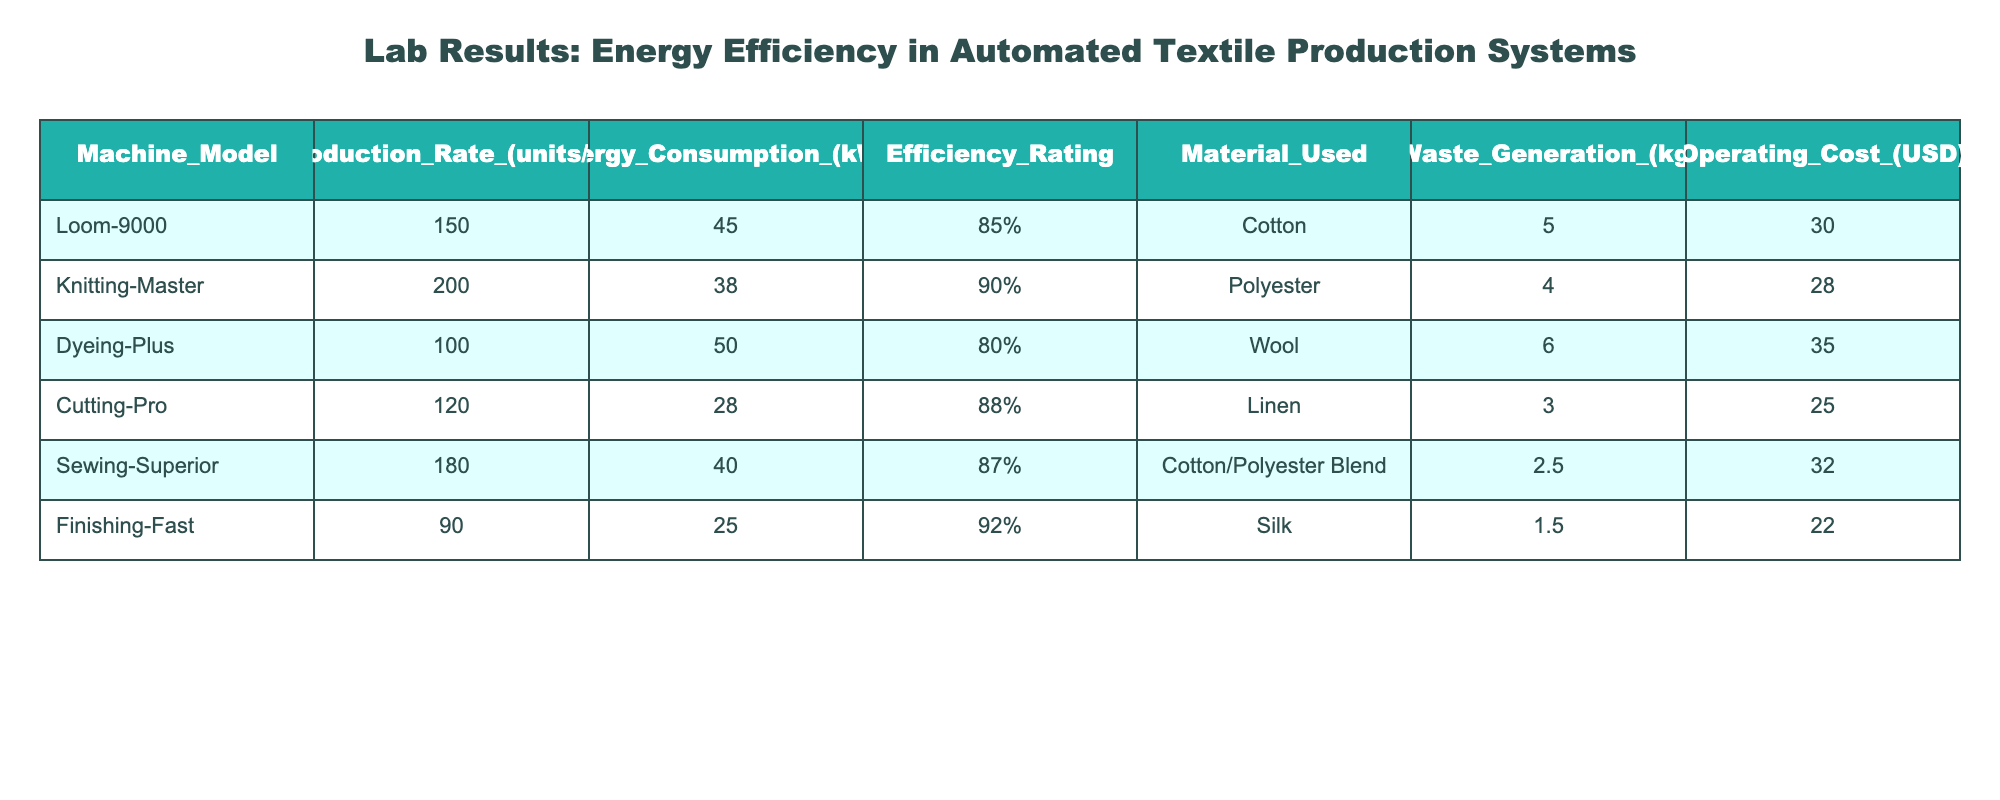What is the production rate of the Loom-9000? The production rate of the Loom-9000 is explicitly listed in the table under the "Production Rate (units/hr)" column, showing a value of 150.
Answer: 150 Which machine has the highest energy consumption? By comparing the values in the "Energy Consumption (kWh)" column, Dyeing-Plus has the highest energy consumption at 50 kWh.
Answer: Dyeing-Plus Is the efficiency rating of the Cutting-Pro higher than that of the Loom-9000? The efficiency rating of the Cutting-Pro is 88%, while the Loom-9000 has an efficiency rating of 85%. Since 88% is greater than 85%, the Cutting-Pro is indeed more efficient.
Answer: Yes What is the total waste generation for all machines combined? To find the total, we sum up the waste generation values: 5 + 4 + 6 + 3 + 2.5 + 1.5 = 22. Therefore, the total waste generation is 22 kg.
Answer: 22 kg Which machine has the lowest operating cost? Looking at the "Operating Cost (USD)" column, Finishing-Fast has the lowest operating cost at 22 USD.
Answer: Finishing-Fast Is the energy efficiency of the Knitting-Master greater than the average efficiency of all machines? The average efficiency can be calculated by adding the efficiency ratings (85% + 90% + 80% + 88% + 87% + 92% = 522%) and dividing by the number of machines (6). Thus, the average efficiency is 522% / 6 = 87%, which is less than the Knitting-Master's efficiency of 90%.
Answer: Yes How many machines have a production rate greater than 100 units per hour? By examining the "Production Rate (units/hr)" values, Loom-9000, Knitting-Master, and Sewing-Superior all have production rates above 100 units/hr (150, 200, and 180 respectively). This gives a total of 3 machines.
Answer: 3 What is the efficiency rating difference between the highest and lowest rated machines? The highest efficiency rating is Finishing-Fast at 92% and the lowest is Dyeing-Plus at 80%. The difference is 92% - 80% = 12%.
Answer: 12% Which material used by machines generates the most waste? By comparing the waste generation associated with each material, Wool, used by Dyeing-Plus, generates the most waste at 6 kg.
Answer: Wool 